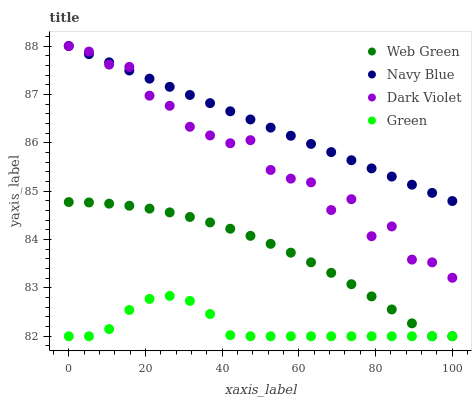Does Green have the minimum area under the curve?
Answer yes or no. Yes. Does Navy Blue have the maximum area under the curve?
Answer yes or no. Yes. Does Dark Violet have the minimum area under the curve?
Answer yes or no. No. Does Dark Violet have the maximum area under the curve?
Answer yes or no. No. Is Navy Blue the smoothest?
Answer yes or no. Yes. Is Dark Violet the roughest?
Answer yes or no. Yes. Is Green the smoothest?
Answer yes or no. No. Is Green the roughest?
Answer yes or no. No. Does Green have the lowest value?
Answer yes or no. Yes. Does Dark Violet have the lowest value?
Answer yes or no. No. Does Dark Violet have the highest value?
Answer yes or no. Yes. Does Green have the highest value?
Answer yes or no. No. Is Green less than Navy Blue?
Answer yes or no. Yes. Is Navy Blue greater than Green?
Answer yes or no. Yes. Does Dark Violet intersect Navy Blue?
Answer yes or no. Yes. Is Dark Violet less than Navy Blue?
Answer yes or no. No. Is Dark Violet greater than Navy Blue?
Answer yes or no. No. Does Green intersect Navy Blue?
Answer yes or no. No. 